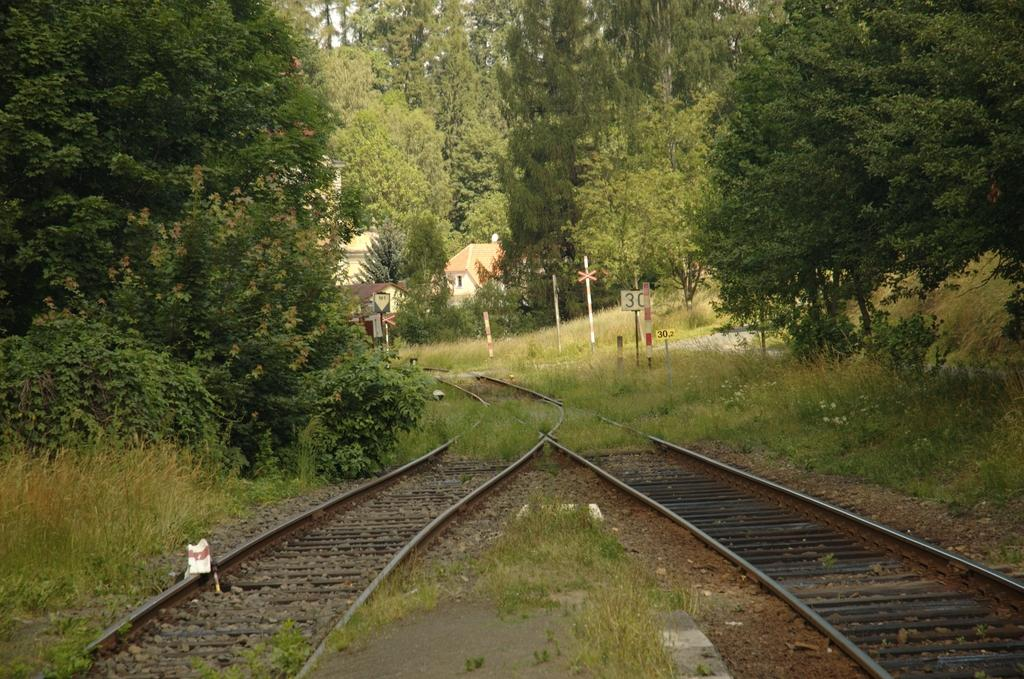What can be seen running parallel to each other in the image? There are two railway tracks in the image. What type of vegetation is present on either side of the tracks? Grass, plants, and trees are present on either side of the tracks. What structures can be seen in the background of the image? There are houses visible in the background of the image. What type of precipitation can be seen falling from the sky in the image? There is no precipitation visible in the image. What sound might be heard coming from the train in the image? There is no train present in the image, so it is not possible to determine what sound might be heard. 